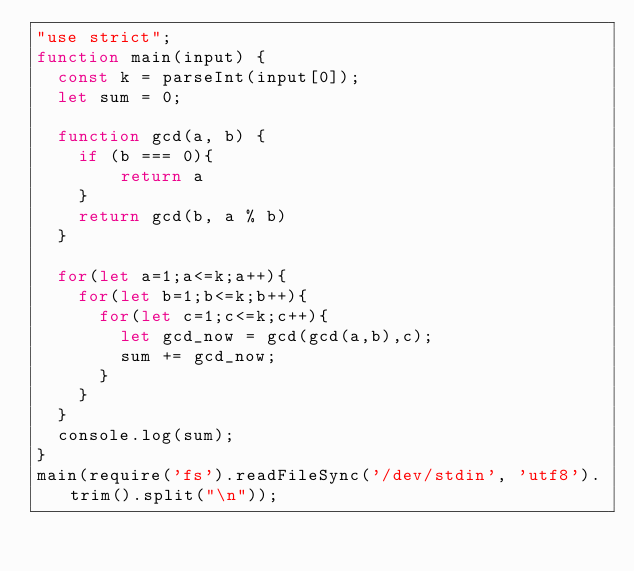Convert code to text. <code><loc_0><loc_0><loc_500><loc_500><_JavaScript_>"use strict";
function main(input) {
  const k = parseInt(input[0]);
  let sum = 0;

  function gcd(a, b) {
    if (b === 0){
        return a
    }
    return gcd(b, a % b)
  }

  for(let a=1;a<=k;a++){
    for(let b=1;b<=k;b++){
      for(let c=1;c<=k;c++){
        let gcd_now = gcd(gcd(a,b),c);
        sum += gcd_now;
      }
    }
  }
  console.log(sum);
}
main(require('fs').readFileSync('/dev/stdin', 'utf8').trim().split("\n"));</code> 